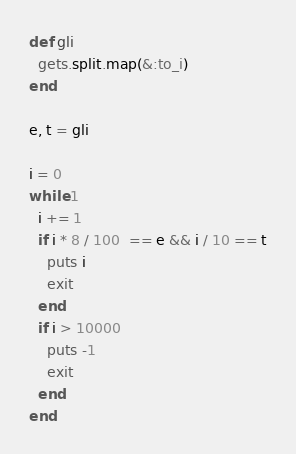<code> <loc_0><loc_0><loc_500><loc_500><_Ruby_>def gli
  gets.split.map(&:to_i)
end

e, t = gli

i = 0
while 1
  i += 1
  if i * 8 / 100  == e && i / 10 == t
    puts i
    exit
  end
  if i > 10000
    puts -1
    exit
  end
end
</code> 